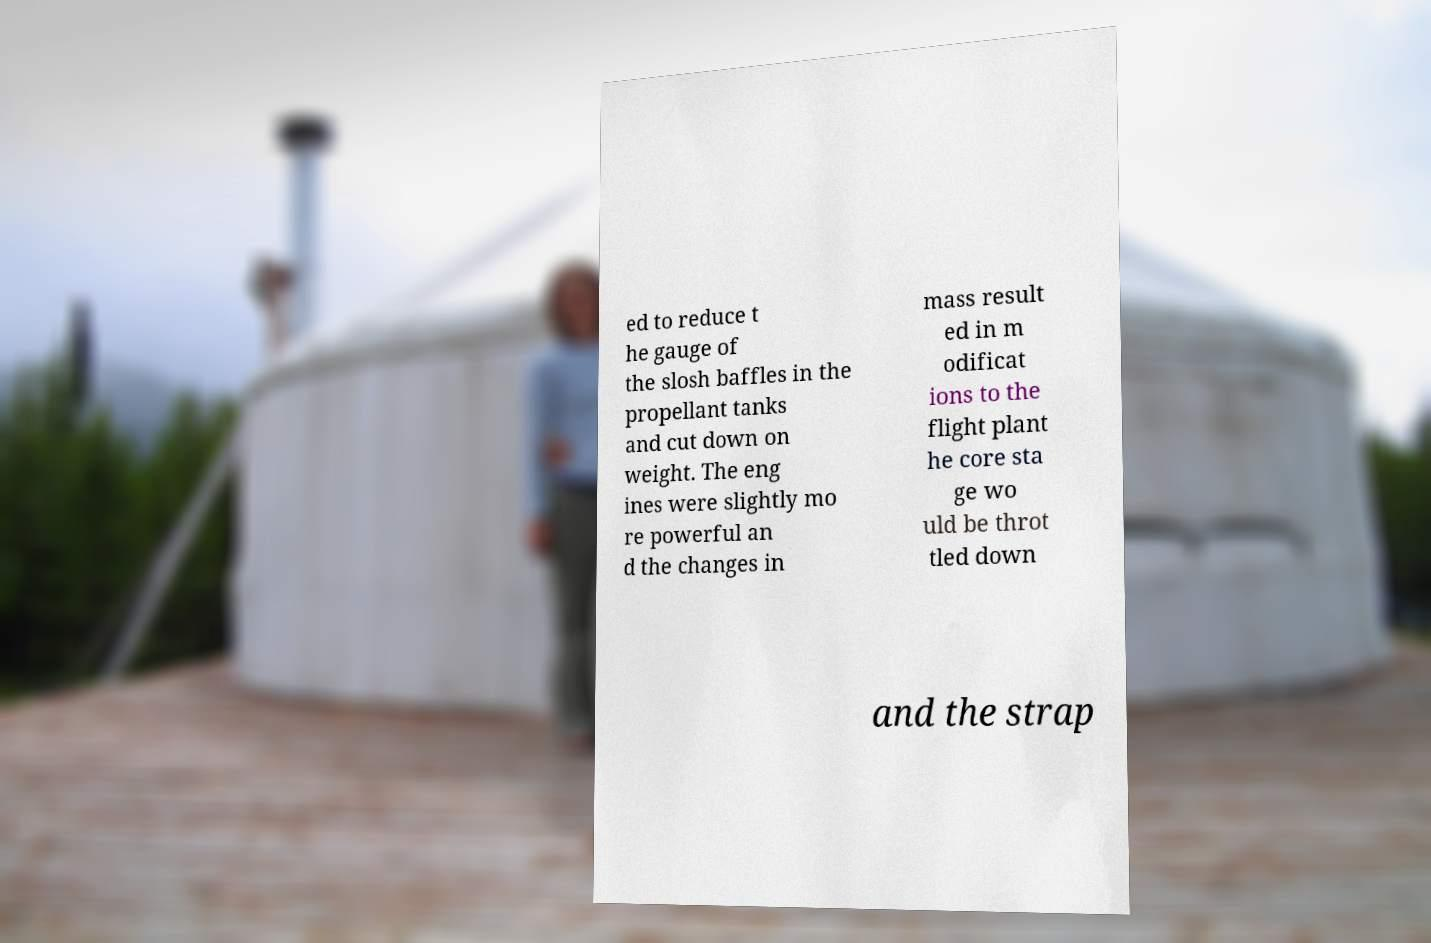What messages or text are displayed in this image? I need them in a readable, typed format. ed to reduce t he gauge of the slosh baffles in the propellant tanks and cut down on weight. The eng ines were slightly mo re powerful an d the changes in mass result ed in m odificat ions to the flight plant he core sta ge wo uld be throt tled down and the strap 